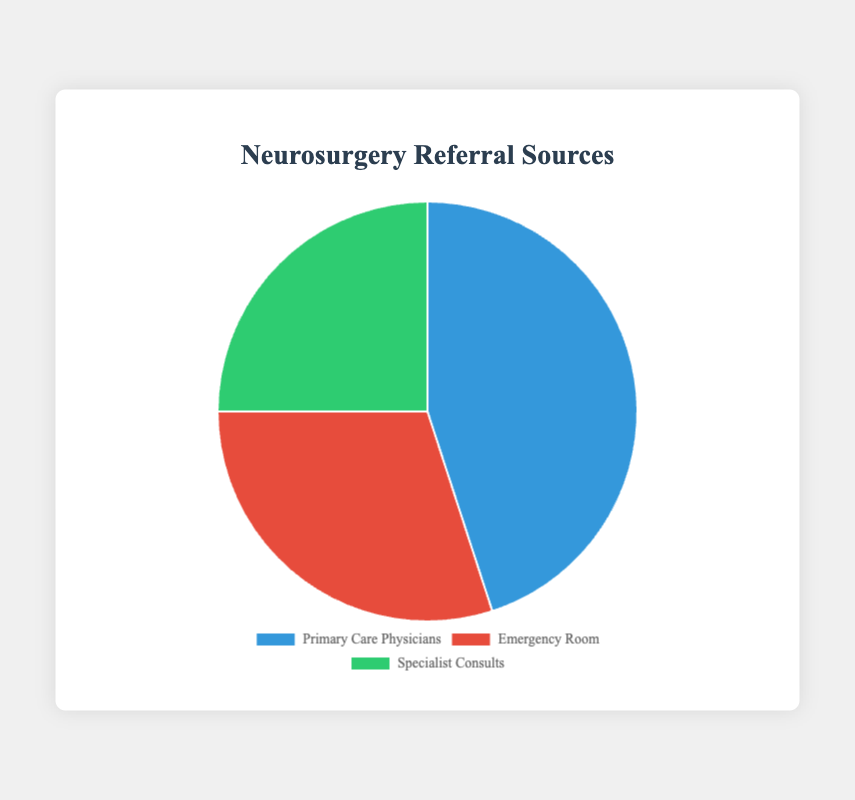What percentage of referrals comes from Emergency Room? The data shows the percentage for each referral source in the pie chart. Emergency Room is one of the sources, and it contributes 30%.
Answer: 30% Which referral source provides the highest percentage of referrals? By comparing the three sources (Primary Care Physicians, Emergency Room, Specialist Consults), we see that Primary Care Physicians have the largest section in the pie chart at 45%.
Answer: Primary Care Physicians How much more is the percentage of referrals from Primary Care Physicians compared to Specialist Consults? The percentage for Primary Care Physicians is 45%, and for Specialist Consults, it is 25%. The difference is calculated as 45% - 25%.
Answer: 20% What is the combined percentage of referrals from Emergency Room and Specialist Consults? The percentage of referrals from the Emergency Room is 30%, and from Specialist Consults is 25%. Adding these together, we get 30% + 25%.
Answer: 55% Which source has the smallest share of referrals? Among the sources (Primary Care Physicians, Emergency Room, Specialist Consults), Specialist Consults have the smallest percentage at 25%.
Answer: Specialist Consults Is the percentage of referrals from Emergency Room greater than from Specialist Consults? The Emergency Room has 30%, and Specialist Consults have 25%. Since 30% is greater than 25%, the answer is yes.
Answer: Yes What portion of the pie chart is blue? By observing the provided colors: Primary Care Physicians are represented by blue, which accounts for 45% of the chart.
Answer: 45% How much larger is the combined percentage of referrals from Primary Care Physicians and Emergency Room compared to Specialist Consults? The sum of Primary Care Physicians (45%) and Emergency Room (30%) is 75%. The percentage for Specialist Consults is 25%. The difference is 75% - 25%.
Answer: 50% What is the average percentage of referrals across all three sources? The percentages are 45% (Primary Care Physicians), 30% (Emergency Room), and 25% (Specialist Consults). Their sum is 100%, and the average is calculated by dividing 100% by 3.
Answer: 33.33% 